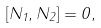Convert formula to latex. <formula><loc_0><loc_0><loc_500><loc_500>[ N _ { 1 } , N _ { 2 } ] = 0 ,</formula> 